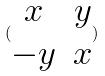Convert formula to latex. <formula><loc_0><loc_0><loc_500><loc_500>( \begin{matrix} x & y \\ - y & x \end{matrix} )</formula> 